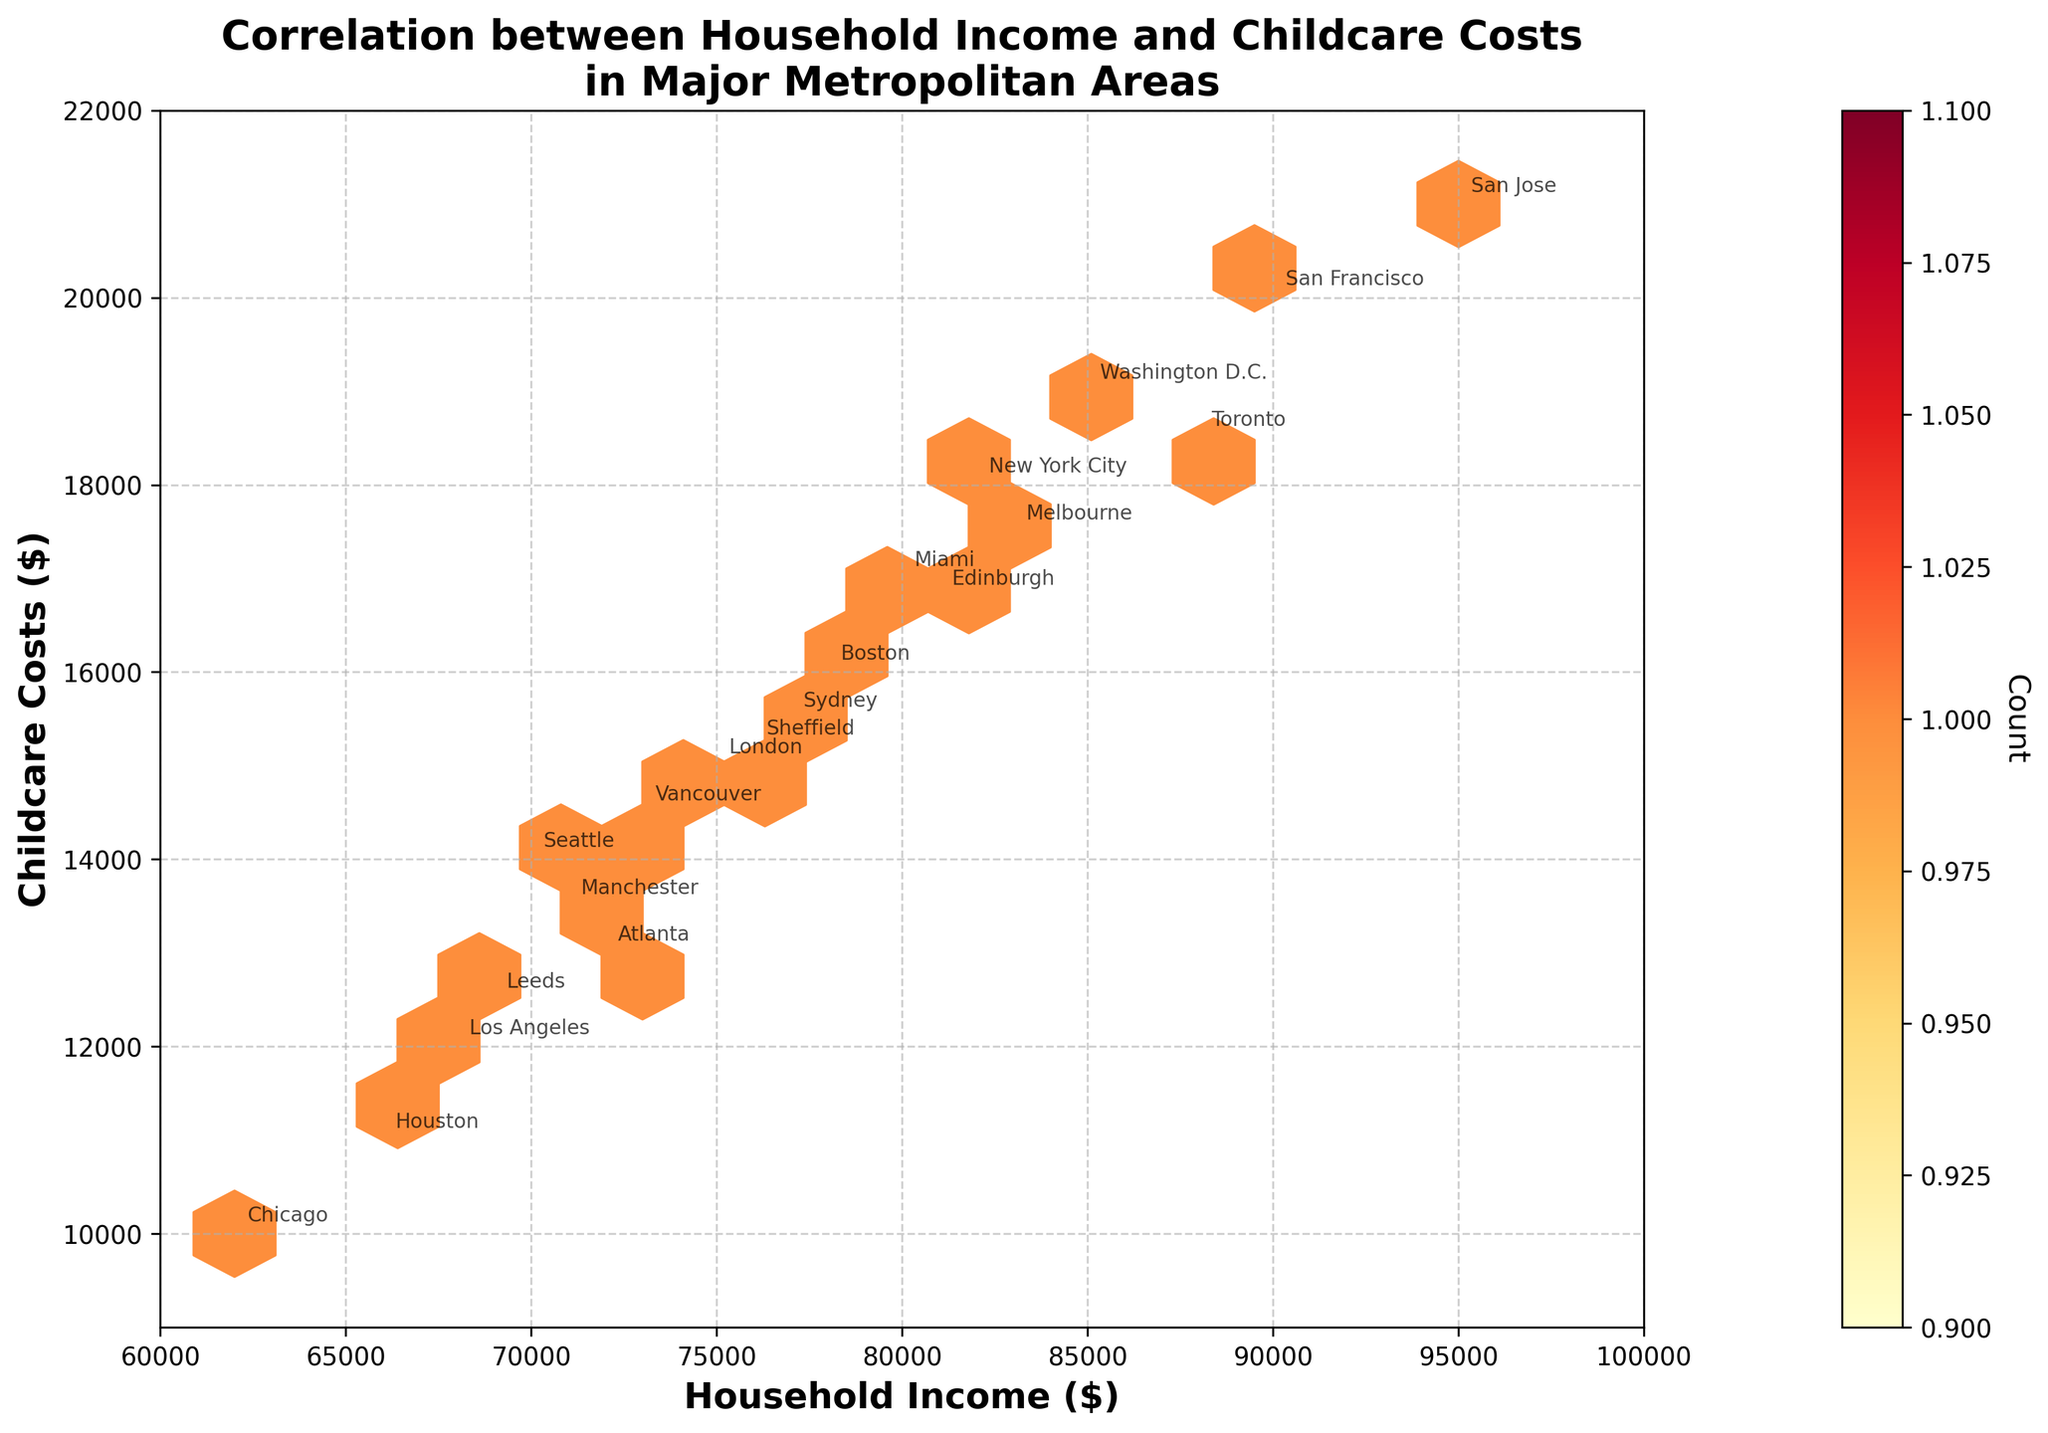What is the title of the figure? The title of the figure is typically located at the top and is intended to summarize the main insight depicted.
Answer: Correlation between Household Income and Childcare Costs in Major Metropolitan Areas What do the x-axis and y-axis represent? The x-axis represents one variable, and the y-axis represents another. In this case, the labels on the axes indicate what each one stands for.
Answer: Household Income and Childcare Costs Which metropolitan area has the highest household income and what are its values? Identify the point farthest to the right on the x-axis and read the annotated text. Check the corresponding value on the x and y axes.
Answer: San Jose, $95,000 household income and $21,000 childcare costs How many metropolitan areas are plotted in the figure? Count the number of different annotated texts on the plot, each representing a unique metropolitan area.
Answer: 20 What is the range of household incomes displayed on the plot? Look at the range on the x-axis from the minimum to maximum value.
Answer: $60,000 - $100,000 Which metropolitan areas fall inside the densest region of the hexbin plot? Look at the cluster with the most darkly colored hexagons, and identify the metropolitan areas by their annotations.
Answer: New York City, Boston, Seattle, and Miami How does the color intensity in the hexbin plot change with the number of overlapping points? Notice the color spectrum and how it shifts from lighter to darker colors, which represent increasing densities of data points.
Answer: Darker colors indicate higher densities For a household income of $80,000, what is the approximate range of childcare costs? Find where $80,000 intersects the x-axis, then trace up to the corresponding points on the plot and check the y-axis values.
Answer: $17,000 - $18,500 Which metropolitan area has the least household income and what are its values? Identify the point farthest to the left on the x-axis and read the annotated text. Check the corresponding value on the x and y axes.
Answer: Chicago, $62,000 household income and $10,000 childcare costs What is the average household income of the metropolitan areas plotted? Sum the household incomes of all the plotted points, then divide by the total number of points.
Answer: ($75000 + $82000 + $68000 + $90000 + $62000 + $78000 + $70000 + $85000 + $72000 + $80000 + $95000 + $66000 + $88000 + $73000 + $77000 + $83000 + $71000 + $76000 + $69000 + $81000) / 20 = $76,100 